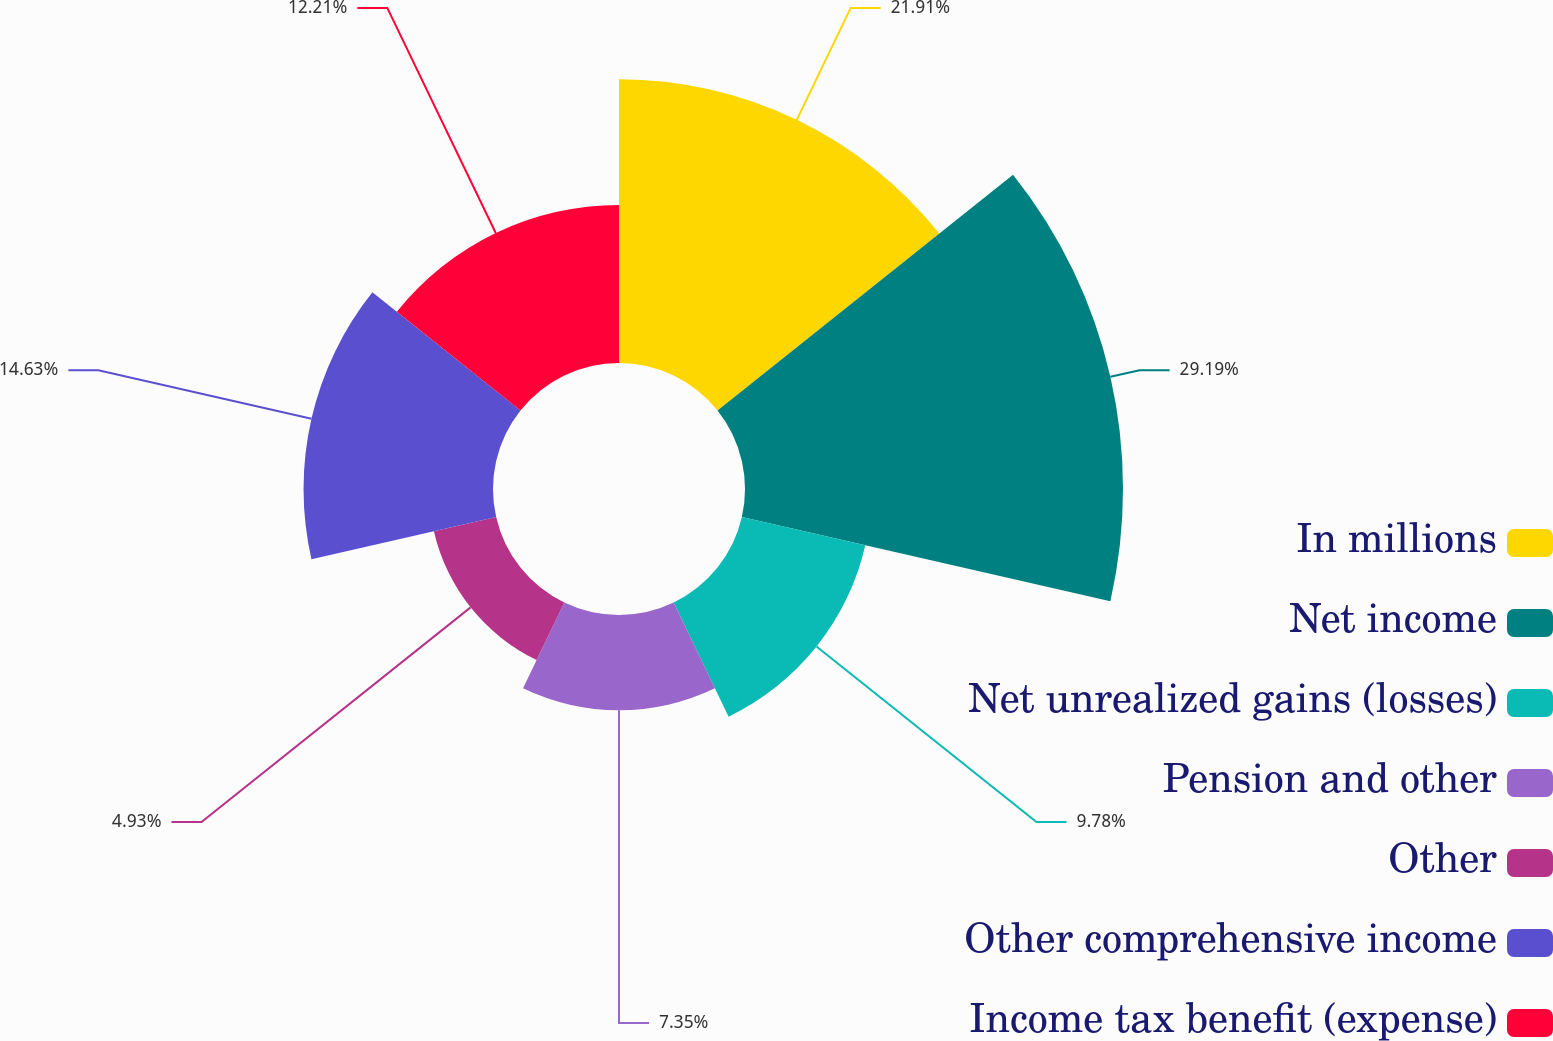<chart> <loc_0><loc_0><loc_500><loc_500><pie_chart><fcel>In millions<fcel>Net income<fcel>Net unrealized gains (losses)<fcel>Pension and other<fcel>Other<fcel>Other comprehensive income<fcel>Income tax benefit (expense)<nl><fcel>21.91%<fcel>29.19%<fcel>9.78%<fcel>7.35%<fcel>4.93%<fcel>14.63%<fcel>12.21%<nl></chart> 